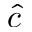<formula> <loc_0><loc_0><loc_500><loc_500>\hat { c }</formula> 